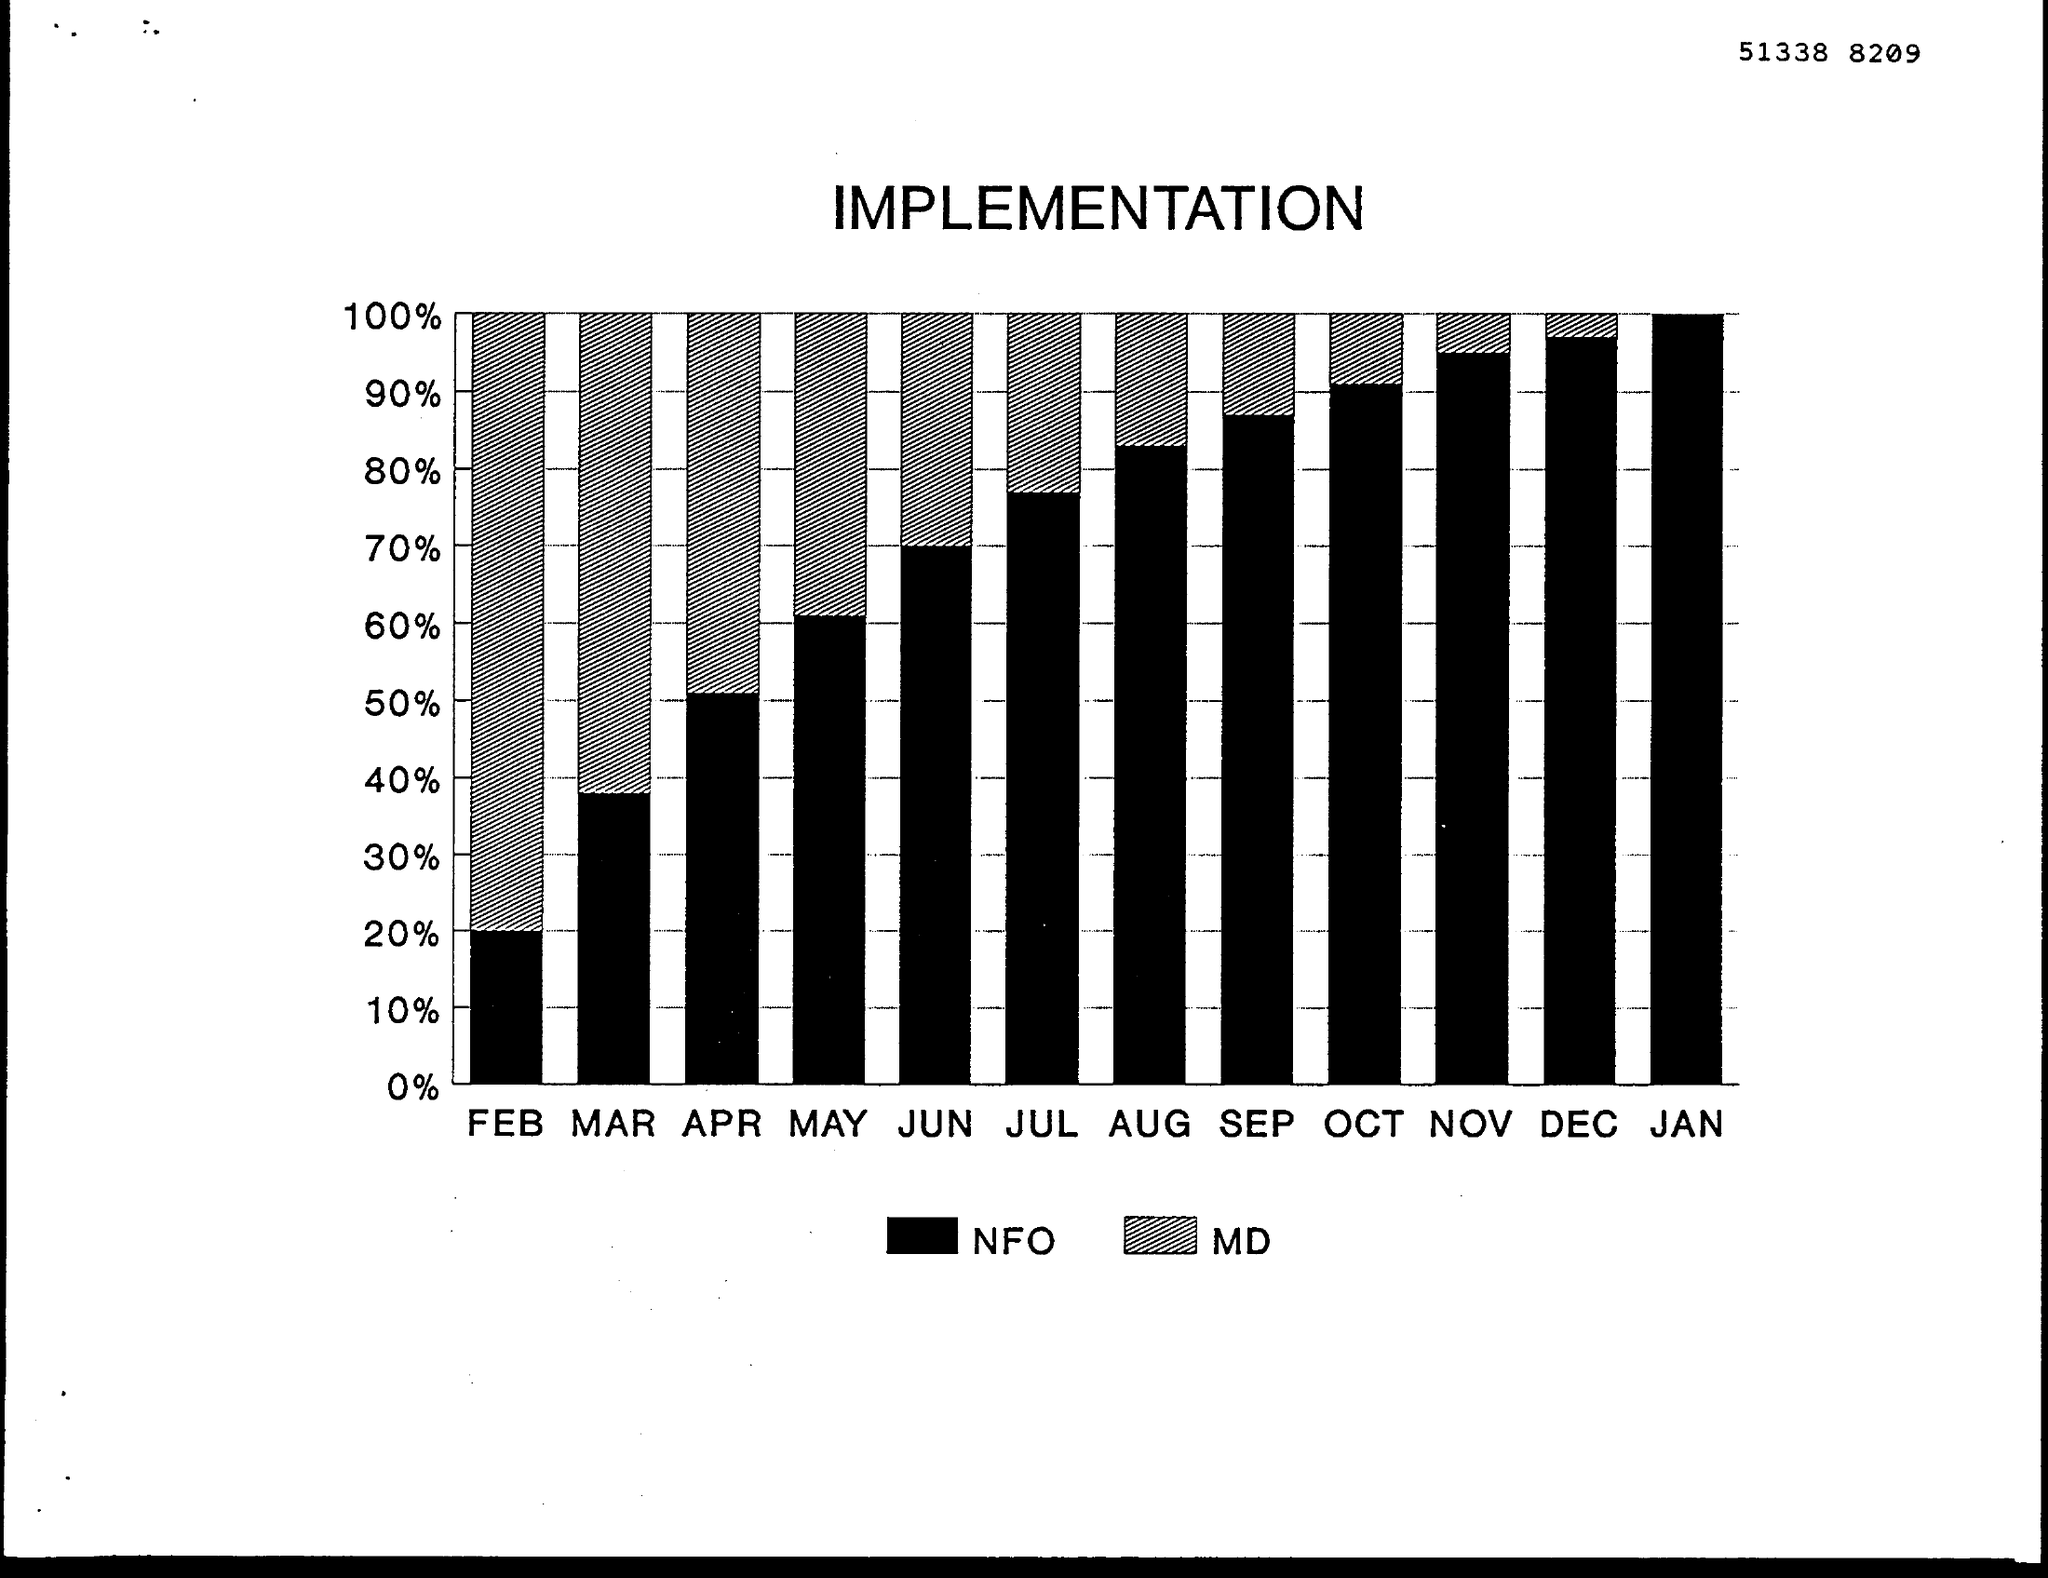Indicate a few pertinent items in this graphic. In June, the implementation of Management by Objectives (MD) was 30%. In the month of April, the implementation of MD was 50%. In the month of February, approximately 80% of the implementation of MD has been completed. The implementation of NFO in the month of January was 100%. In the month of October, the implementation of NFO was 90%. 